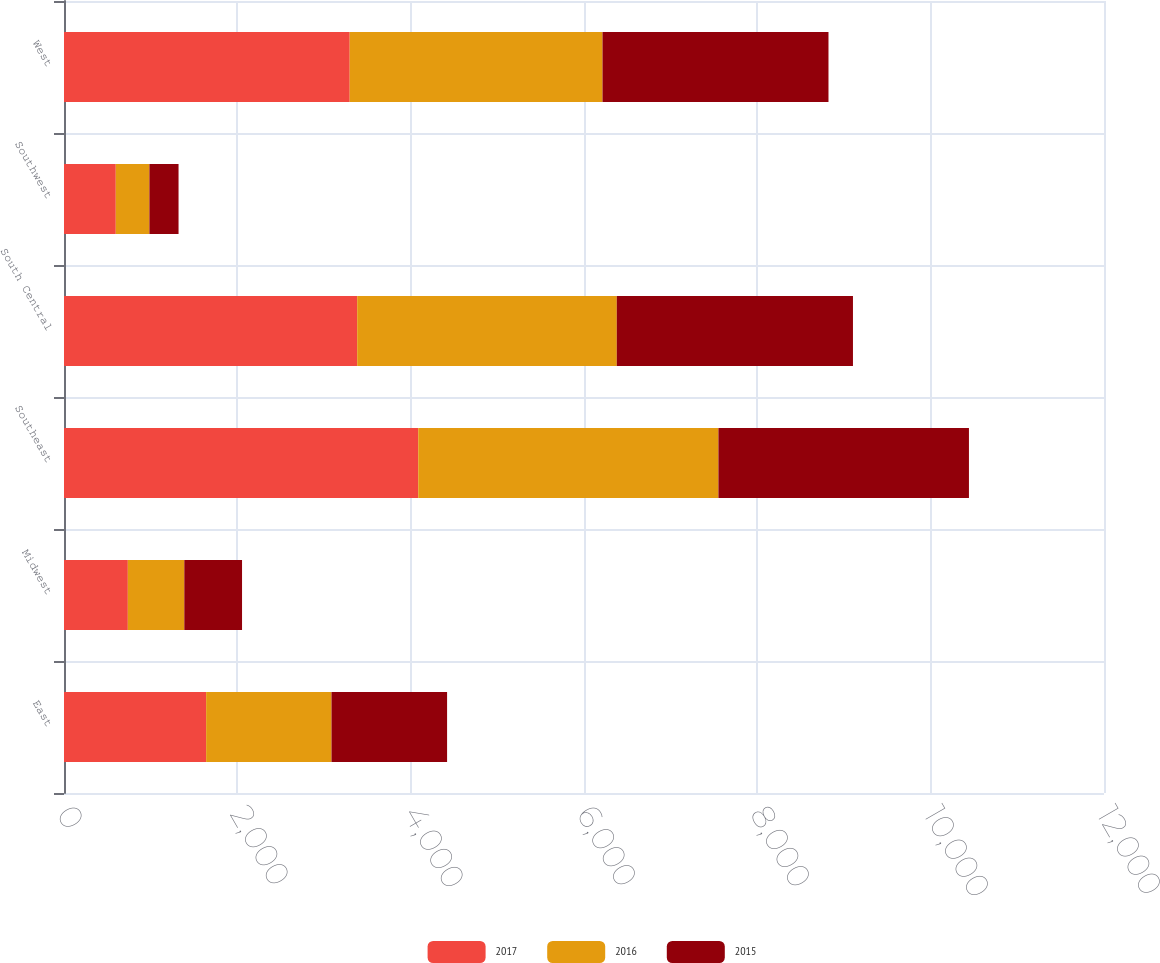Convert chart to OTSL. <chart><loc_0><loc_0><loc_500><loc_500><stacked_bar_chart><ecel><fcel>East<fcel>Midwest<fcel>Southeast<fcel>South Central<fcel>Southwest<fcel>West<nl><fcel>2017<fcel>1640.1<fcel>736.5<fcel>4087.6<fcel>3383.1<fcel>597.5<fcel>3296.7<nl><fcel>2016<fcel>1446.5<fcel>651.7<fcel>3463.5<fcel>2995.1<fcel>388.1<fcel>2916.9<nl><fcel>2015<fcel>1333.6<fcel>666.1<fcel>2890.6<fcel>2725.2<fcel>336.1<fcel>2607.4<nl></chart> 